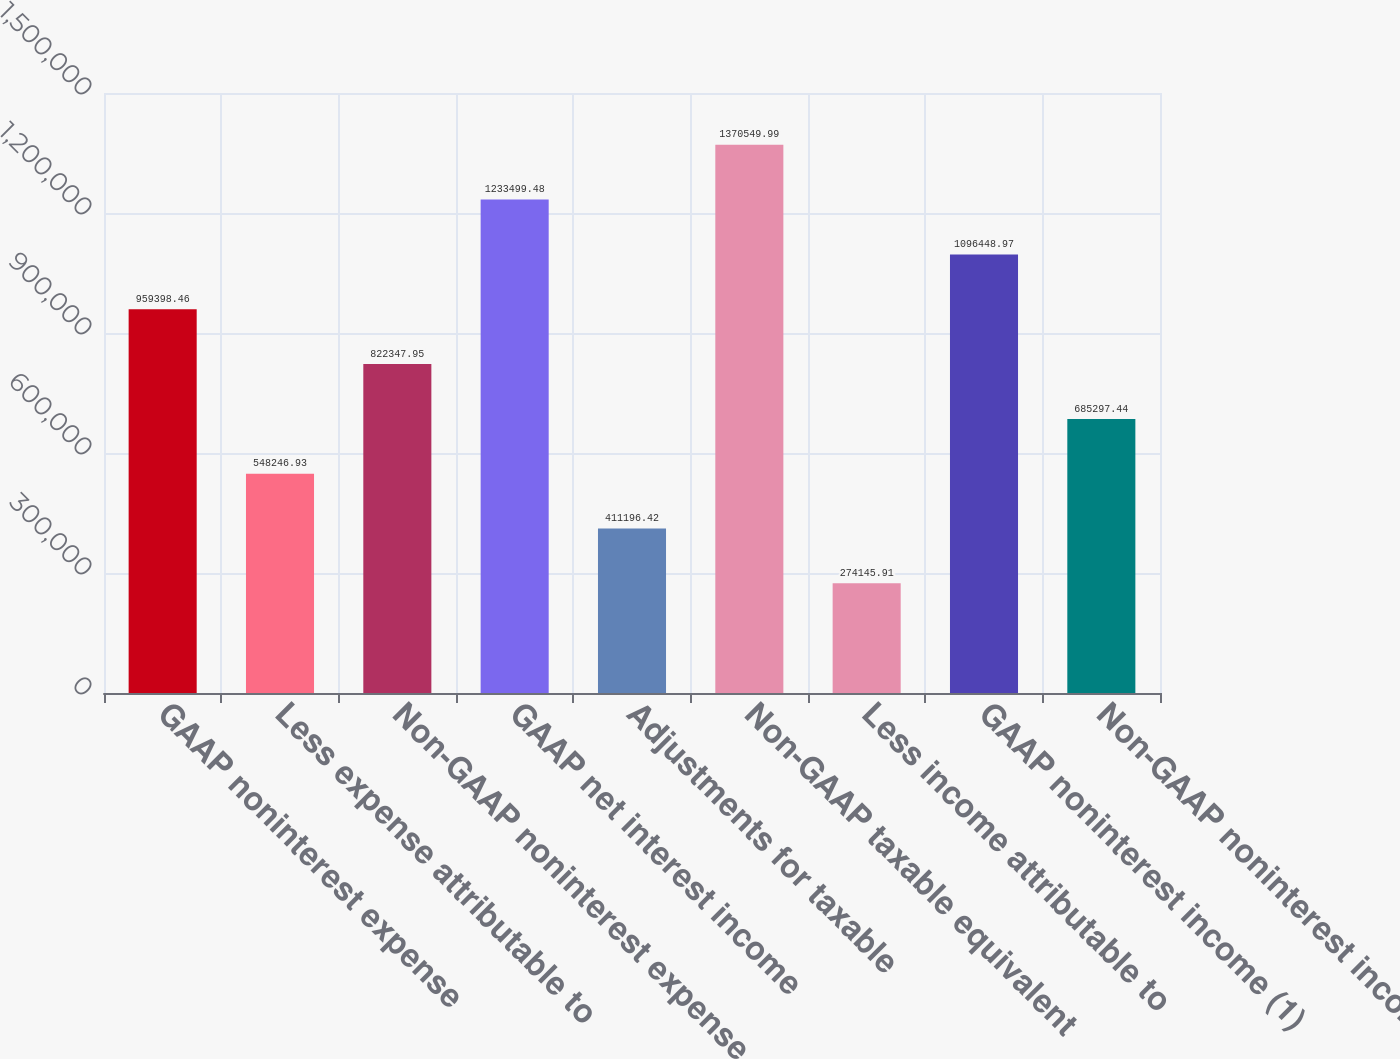Convert chart. <chart><loc_0><loc_0><loc_500><loc_500><bar_chart><fcel>GAAP noninterest expense<fcel>Less expense attributable to<fcel>Non-GAAP noninterest expense<fcel>GAAP net interest income<fcel>Adjustments for taxable<fcel>Non-GAAP taxable equivalent<fcel>Less income attributable to<fcel>GAAP noninterest income (1)<fcel>Non-GAAP noninterest income<nl><fcel>959398<fcel>548247<fcel>822348<fcel>1.2335e+06<fcel>411196<fcel>1.37055e+06<fcel>274146<fcel>1.09645e+06<fcel>685297<nl></chart> 